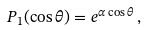<formula> <loc_0><loc_0><loc_500><loc_500>P _ { 1 } ( \cos { \theta } ) = e ^ { \alpha \cos { \theta } } \, ,</formula> 